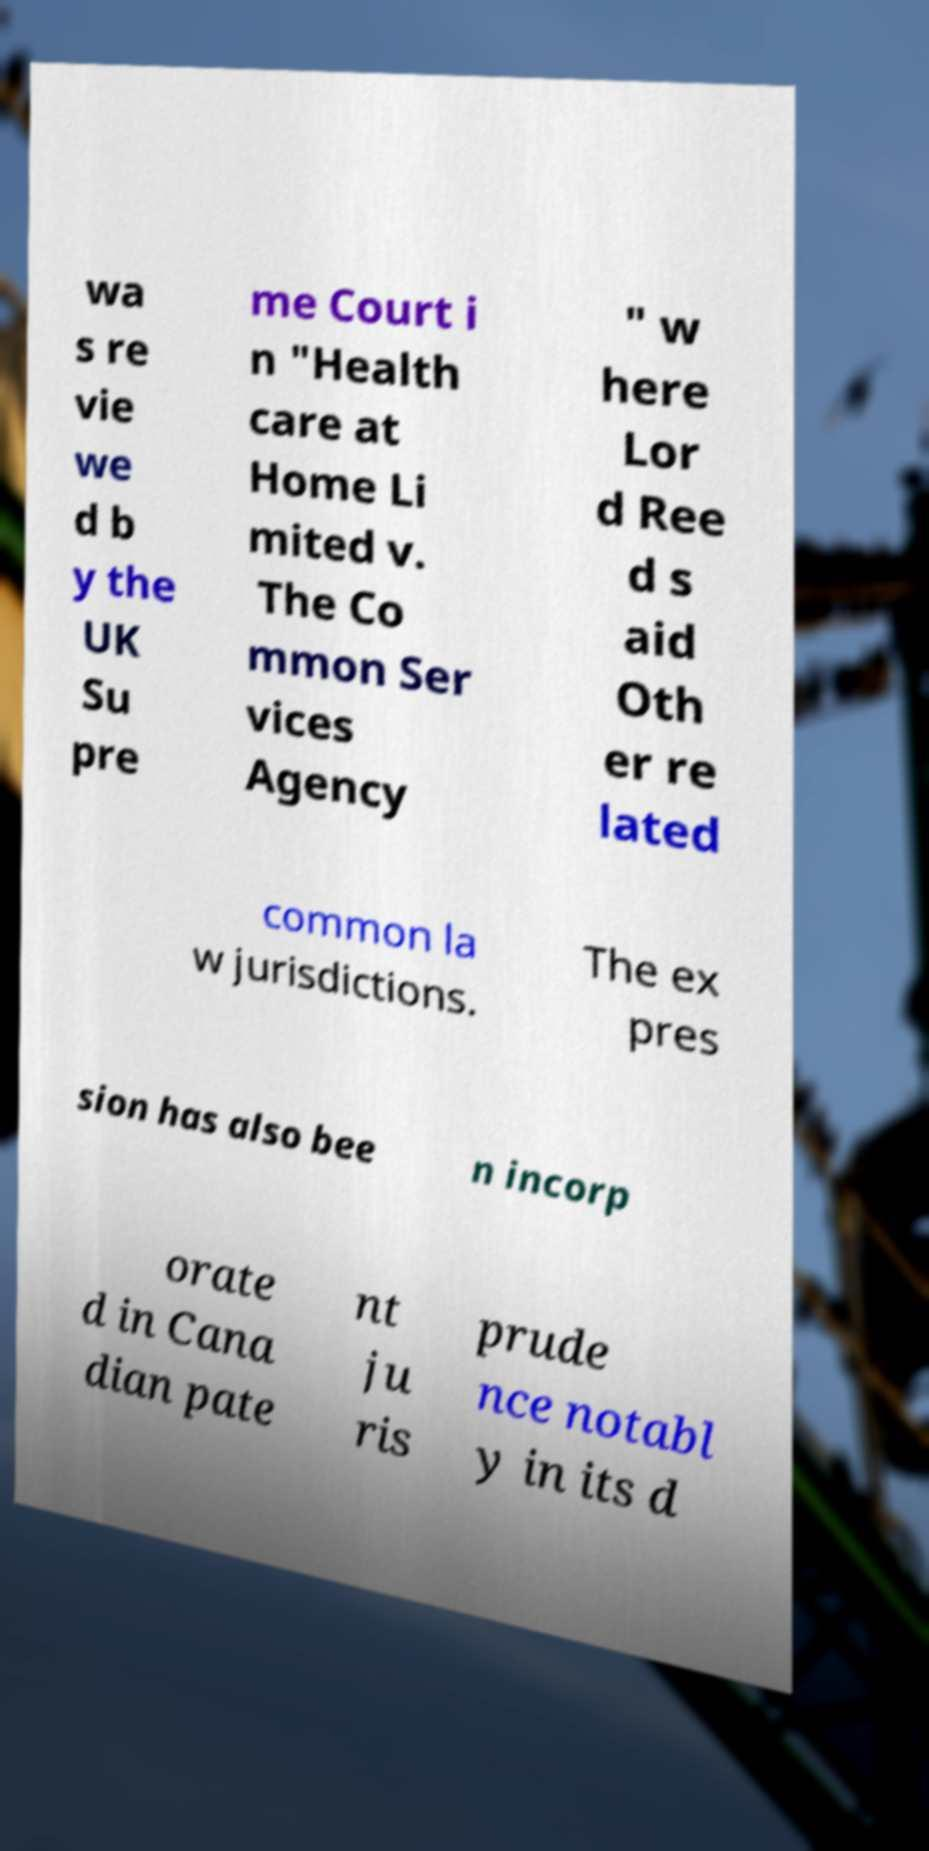There's text embedded in this image that I need extracted. Can you transcribe it verbatim? wa s re vie we d b y the UK Su pre me Court i n "Health care at Home Li mited v. The Co mmon Ser vices Agency " w here Lor d Ree d s aid Oth er re lated common la w jurisdictions. The ex pres sion has also bee n incorp orate d in Cana dian pate nt ju ris prude nce notabl y in its d 